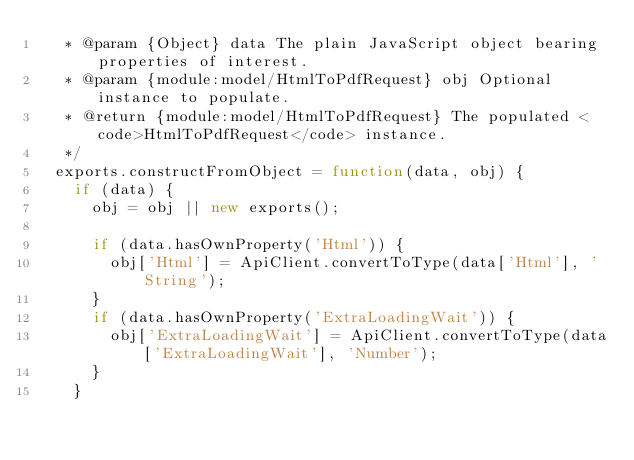<code> <loc_0><loc_0><loc_500><loc_500><_JavaScript_>   * @param {Object} data The plain JavaScript object bearing properties of interest.
   * @param {module:model/HtmlToPdfRequest} obj Optional instance to populate.
   * @return {module:model/HtmlToPdfRequest} The populated <code>HtmlToPdfRequest</code> instance.
   */
  exports.constructFromObject = function(data, obj) {
    if (data) {
      obj = obj || new exports();

      if (data.hasOwnProperty('Html')) {
        obj['Html'] = ApiClient.convertToType(data['Html'], 'String');
      }
      if (data.hasOwnProperty('ExtraLoadingWait')) {
        obj['ExtraLoadingWait'] = ApiClient.convertToType(data['ExtraLoadingWait'], 'Number');
      }
    }</code> 